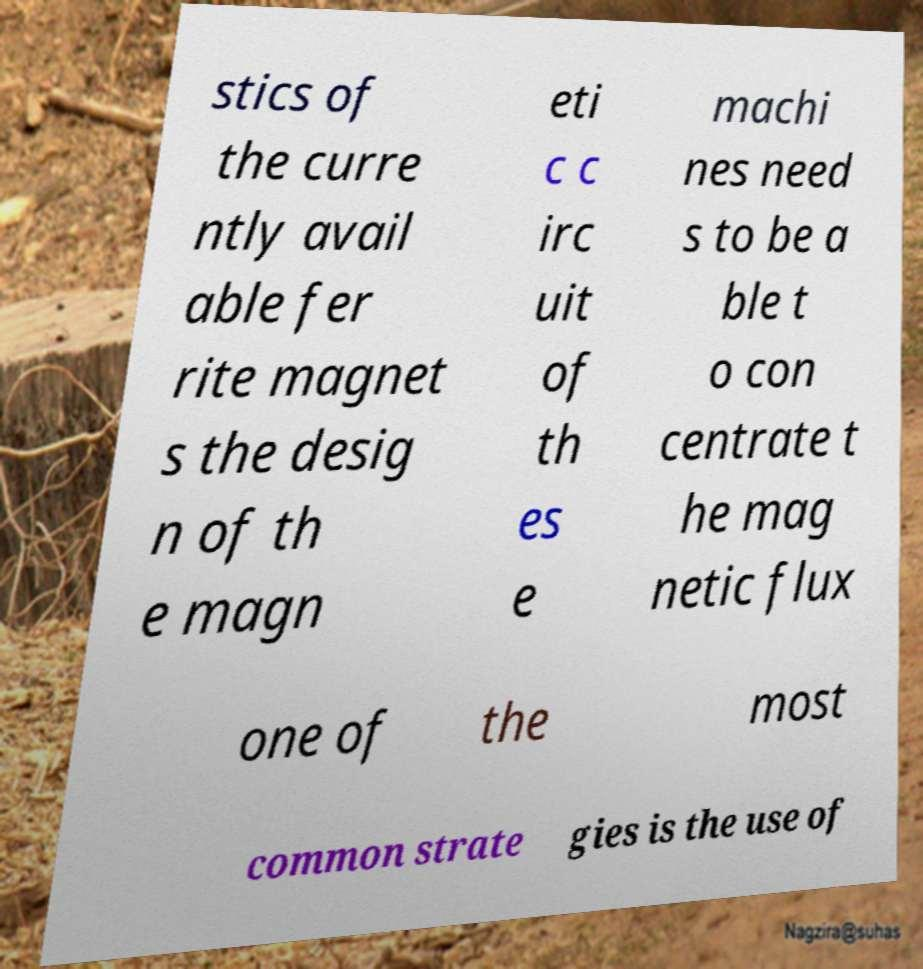Could you extract and type out the text from this image? stics of the curre ntly avail able fer rite magnet s the desig n of th e magn eti c c irc uit of th es e machi nes need s to be a ble t o con centrate t he mag netic flux one of the most common strate gies is the use of 